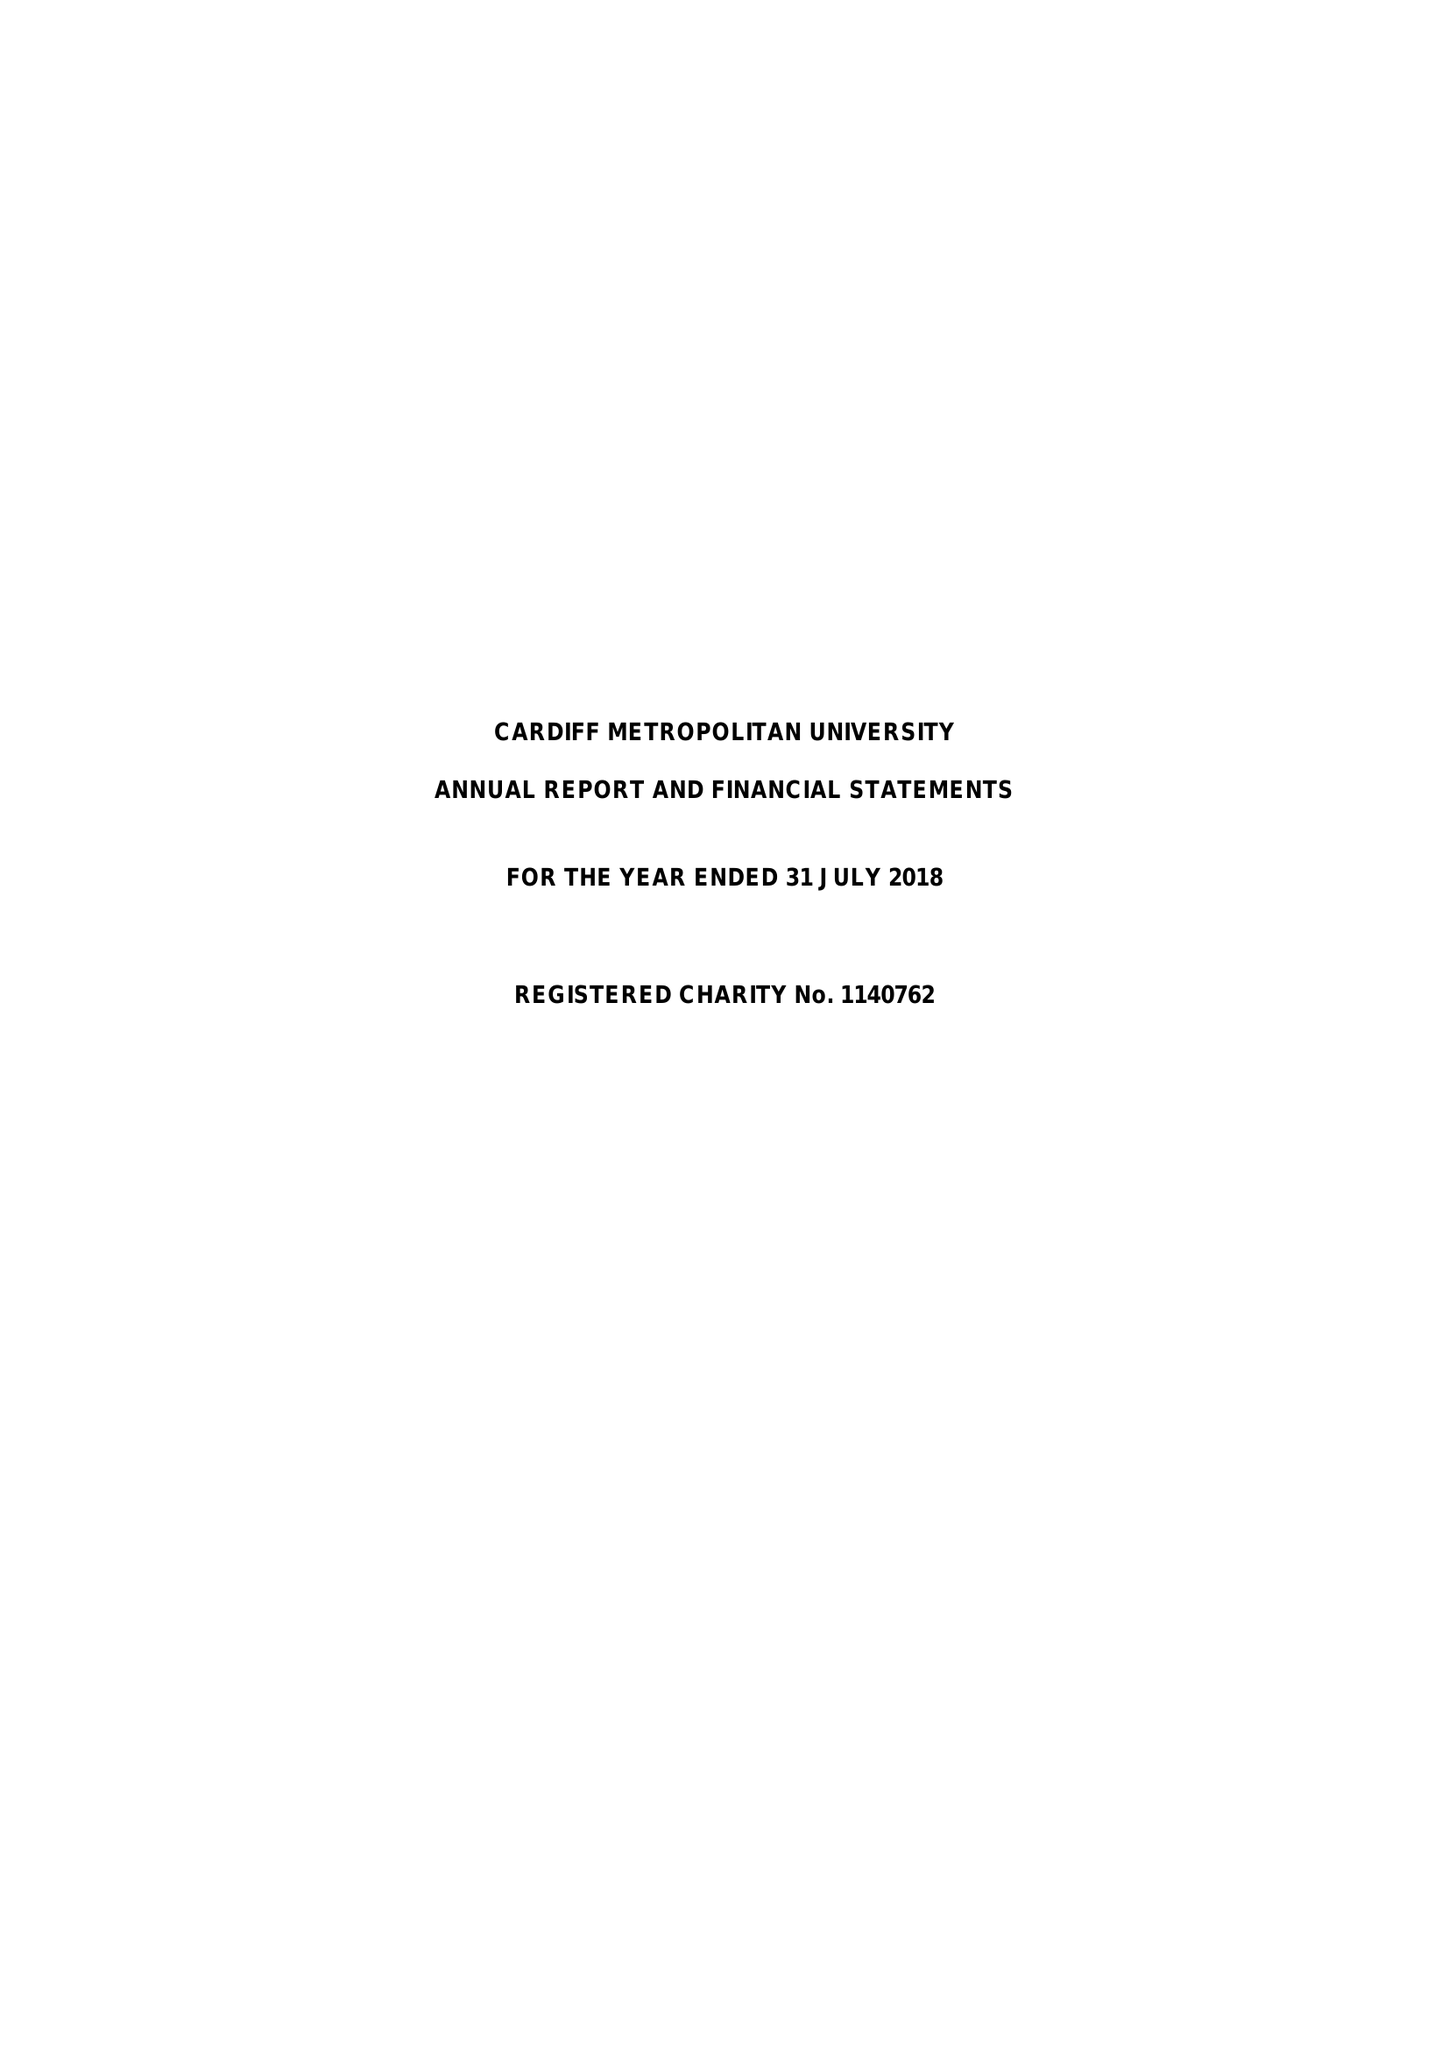What is the value for the income_annually_in_british_pounds?
Answer the question using a single word or phrase. 103695000.00 